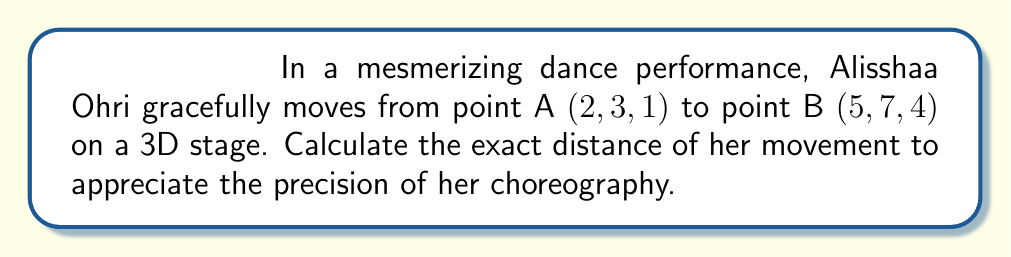Show me your answer to this math problem. To calculate the distance between two points in 3D space, we use the distance formula:

$$d = \sqrt{(x_2 - x_1)^2 + (y_2 - y_1)^2 + (z_2 - z_1)^2}$$

Where $(x_1, y_1, z_1)$ are the coordinates of the first point and $(x_2, y_2, z_2)$ are the coordinates of the second point.

Given:
Point A $(x_1, y_1, z_1) = (2, 3, 1)$
Point B $(x_2, y_2, z_2) = (5, 7, 4)$

Step 1: Calculate the differences:
$x_2 - x_1 = 5 - 2 = 3$
$y_2 - y_1 = 7 - 3 = 4$
$z_2 - z_1 = 4 - 1 = 3$

Step 2: Square the differences:
$(x_2 - x_1)^2 = 3^2 = 9$
$(y_2 - y_1)^2 = 4^2 = 16$
$(z_2 - z_1)^2 = 3^2 = 9$

Step 3: Sum the squared differences:
$9 + 16 + 9 = 34$

Step 4: Calculate the square root:
$d = \sqrt{34}$

Therefore, the exact distance of Alisshaa Ohri's movement is $\sqrt{34}$ units.
Answer: $\sqrt{34}$ units 